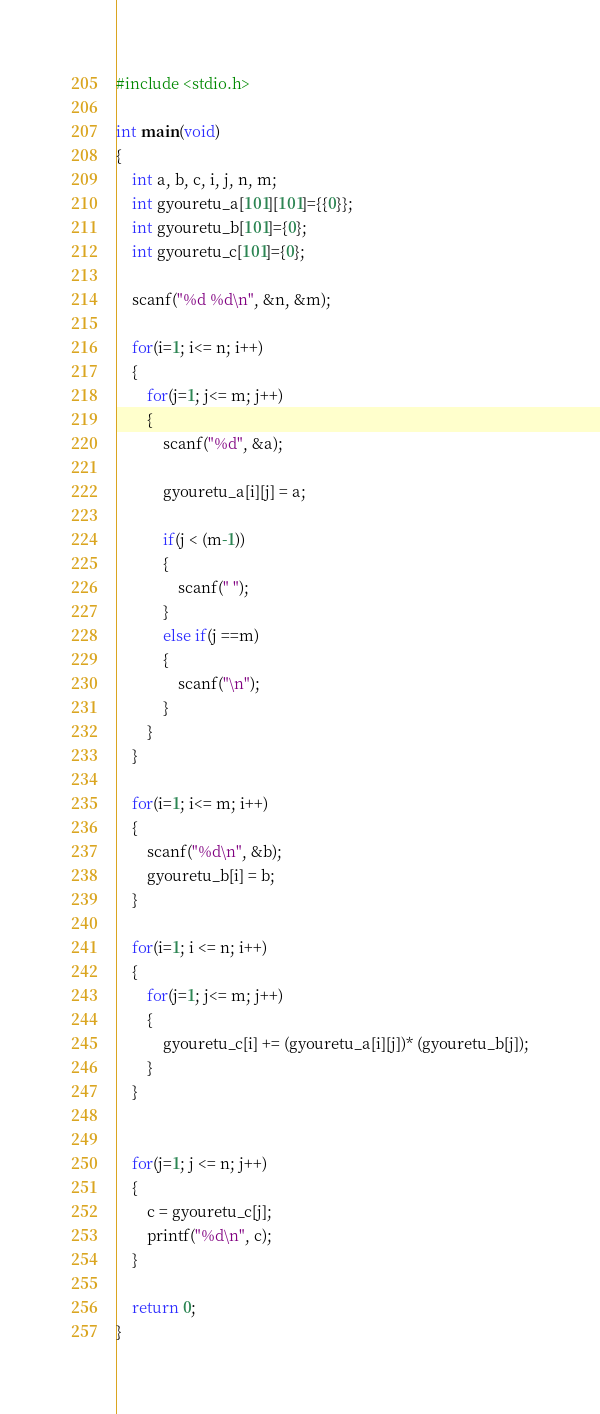<code> <loc_0><loc_0><loc_500><loc_500><_C_>#include <stdio.h>
 
int main(void)
{
    int a, b, c, i, j, n, m;
    int gyouretu_a[101][101]={{0}};
	int gyouretu_b[101]={0};
	int gyouretu_c[101]={0};
     
    scanf("%d %d\n", &n, &m);
 
    for(i=1; i<= n; i++)
	{
        for(j=1; j<= m; j++)
		{
            scanf("%d", &a);
            
			gyouretu_a[i][j] = a;
 
            if(j < (m-1))
			{
                scanf(" ");
            }
			else if(j ==m)
			{
                scanf("\n");
            }
        }
    }
     
    for(i=1; i<= m; i++)
	{
		scanf("%d\n", &b);
        gyouretu_b[i] = b;
    }
 
    for(i=1; i <= n; i++)
	{
        for(j=1; j<= m; j++)
		{
            gyouretu_c[i] += (gyouretu_a[i][j])* (gyouretu_b[j]);
        }
    }
     
     
    for(j=1; j <= n; j++)
	{
        c = gyouretu_c[j];
        printf("%d\n", c);
    }
     
    return 0;
}</code> 